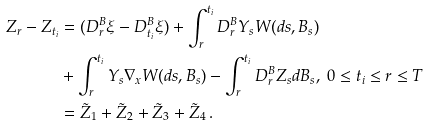<formula> <loc_0><loc_0><loc_500><loc_500>Z _ { r } - Z _ { t _ { i } } & = ( D _ { r } ^ { B } \xi - D _ { t _ { i } } ^ { B } \xi ) + \int _ { r } ^ { t _ { i } } D _ { r } ^ { B } Y _ { s } { W } ( d s , B _ { s } ) \\ & + \int _ { r } ^ { t _ { i } } Y _ { s } \nabla _ { x } { W } ( d s , B _ { s } ) - \int _ { r } ^ { t _ { i } } D _ { r } ^ { B } Z _ { s } d B _ { s } , \ 0 \leq t _ { i } \leq r \leq T \\ & = \tilde { Z } _ { 1 } + \tilde { Z } _ { 2 } + \tilde { Z } _ { 3 } + \tilde { Z } _ { 4 } \, .</formula> 